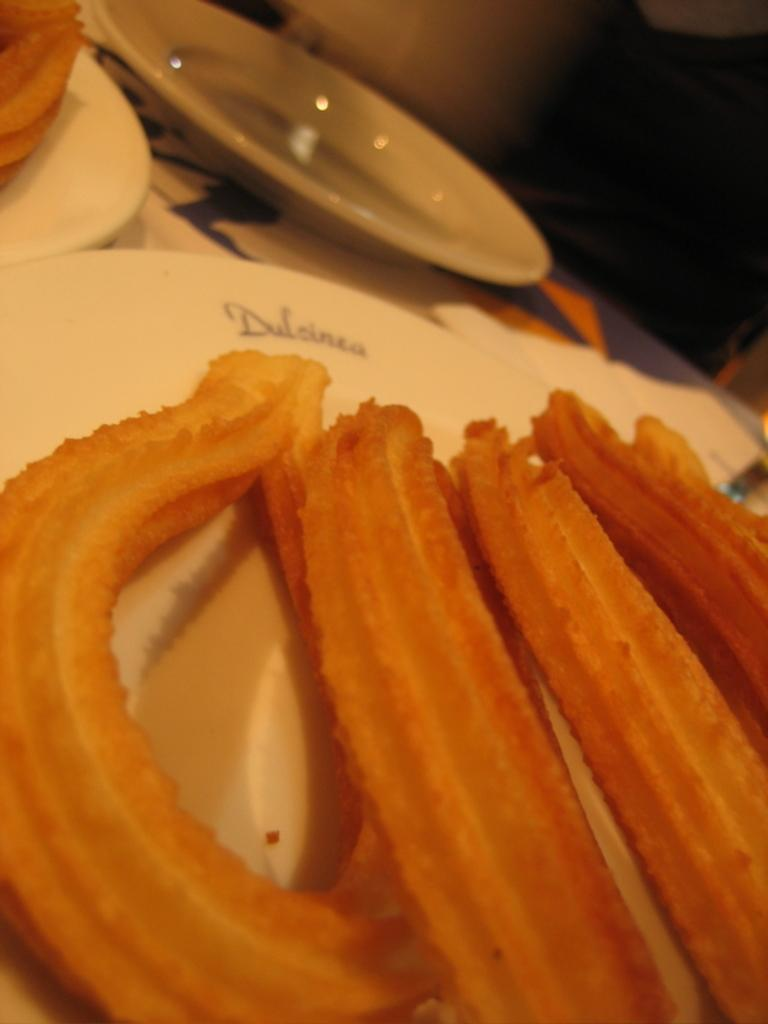What can be seen in the image related to food? There are food items in the image. How are the food items arranged or presented? The food items are kept on a plate. What time of day is the father using a hammer in the image? There is no father or hammer present in the image; it only features food items on a plate. 